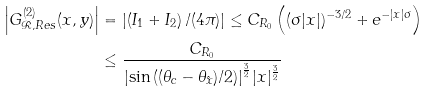Convert formula to latex. <formula><loc_0><loc_0><loc_500><loc_500>\left | G ^ { ( 2 ) } _ { \mathcal { R } , R e s } ( x , y ) \right | & = \left | \left ( I _ { 1 } + I _ { 2 } \right ) / ( 4 \pi ) \right | \leq C _ { R _ { 0 } } \left ( ( \sigma | x | ) ^ { - 3 / 2 } + e ^ { - | x | \sigma } \right ) \\ & \leq \frac { C _ { R _ { 0 } } } { { { \left | \sin \left ( { ( \theta _ { c } - \theta _ { \hat { x } } ) } / 2 \right ) \right | } ^ { \frac { 3 } { 2 } } } | x | ^ { \frac { 3 } { 2 } } }</formula> 